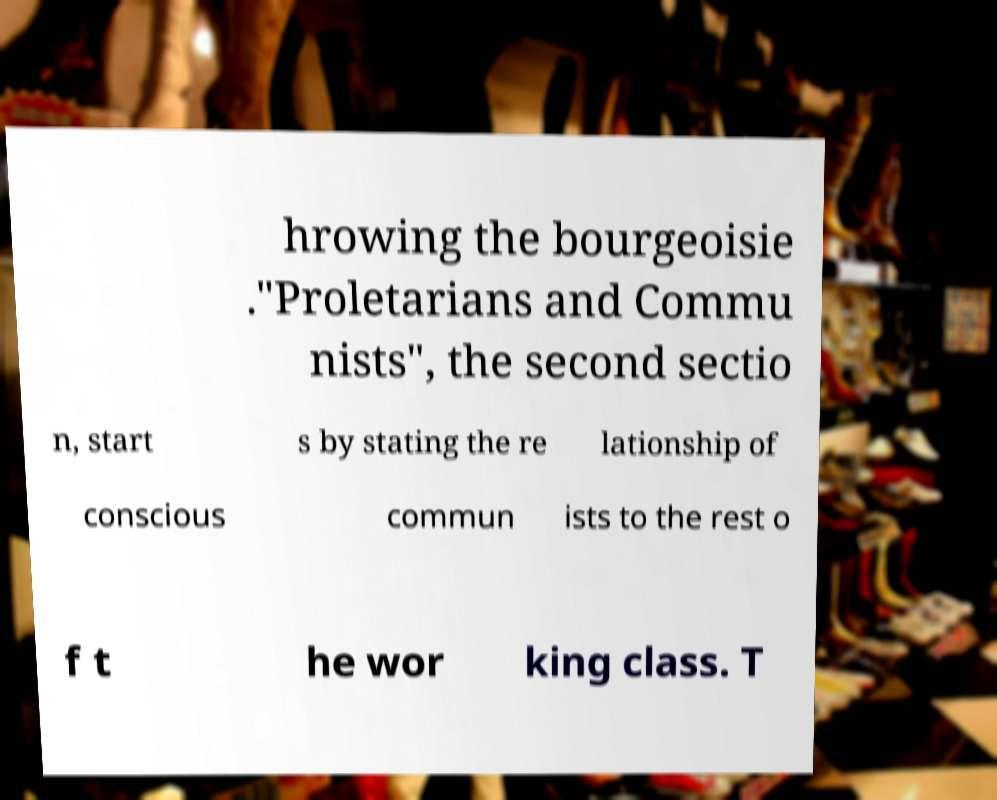There's text embedded in this image that I need extracted. Can you transcribe it verbatim? hrowing the bourgeoisie ."Proletarians and Commu nists", the second sectio n, start s by stating the re lationship of conscious commun ists to the rest o f t he wor king class. T 